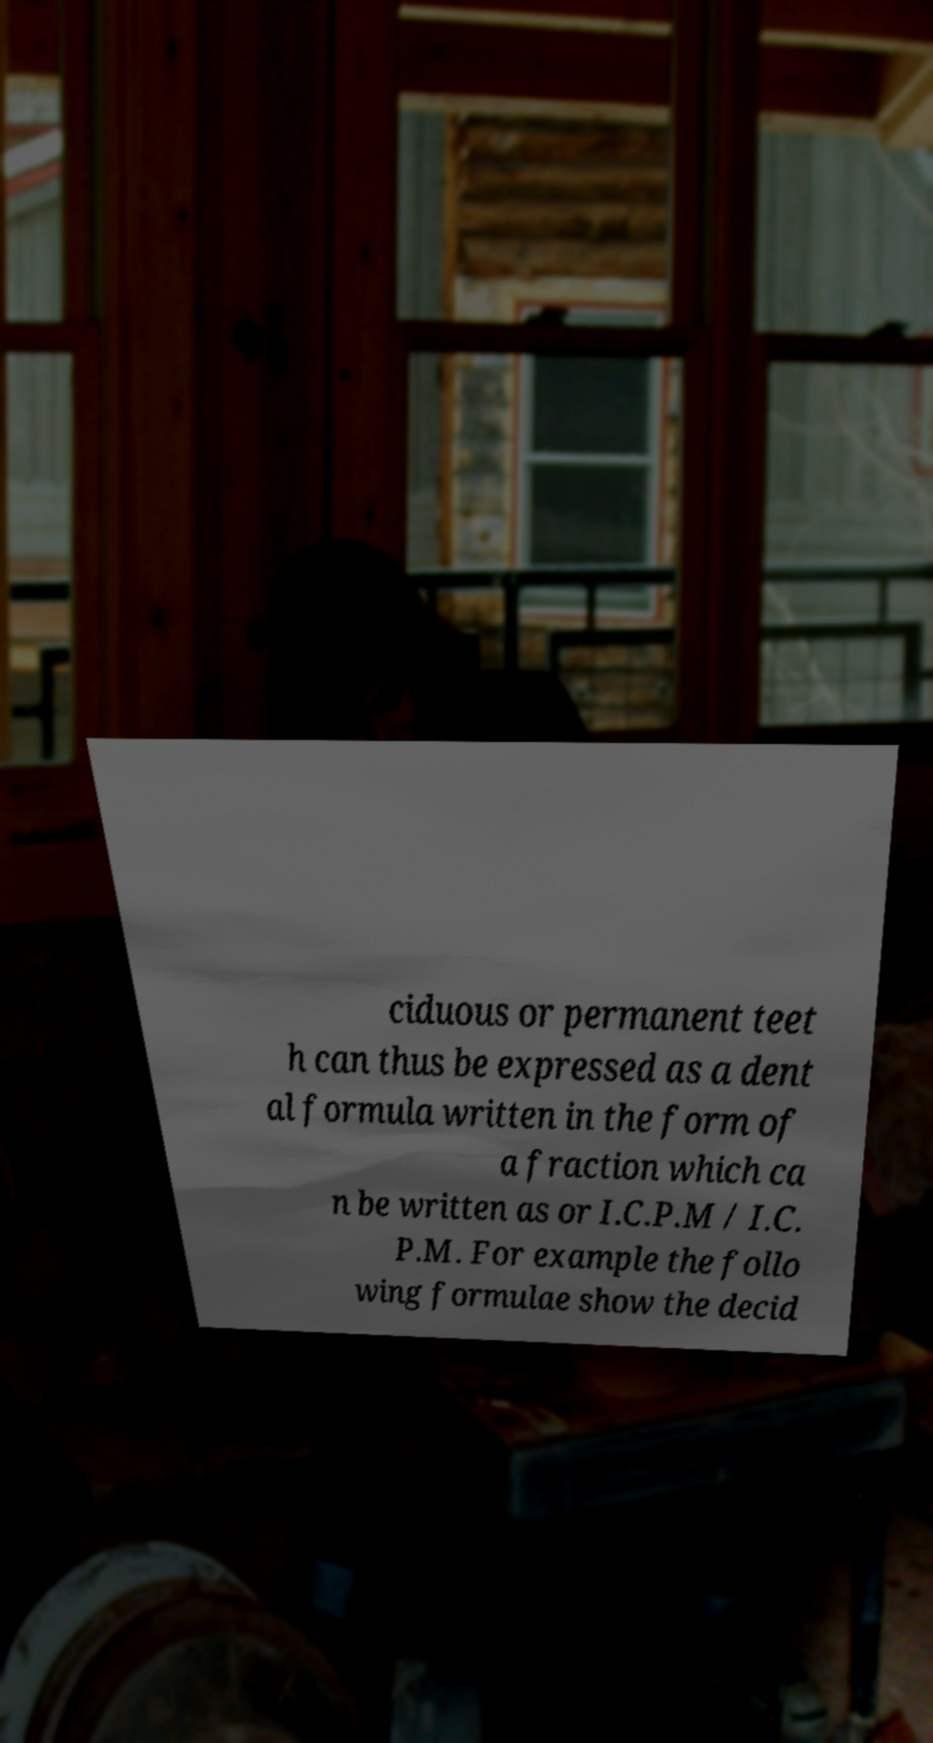Can you accurately transcribe the text from the provided image for me? ciduous or permanent teet h can thus be expressed as a dent al formula written in the form of a fraction which ca n be written as or I.C.P.M / I.C. P.M. For example the follo wing formulae show the decid 